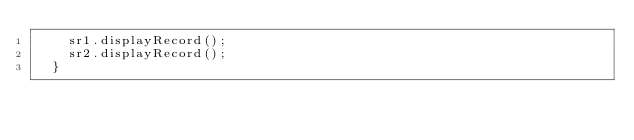<code> <loc_0><loc_0><loc_500><loc_500><_Java_>		sr1.displayRecord();
		sr2.displayRecord();
	}
	</code> 